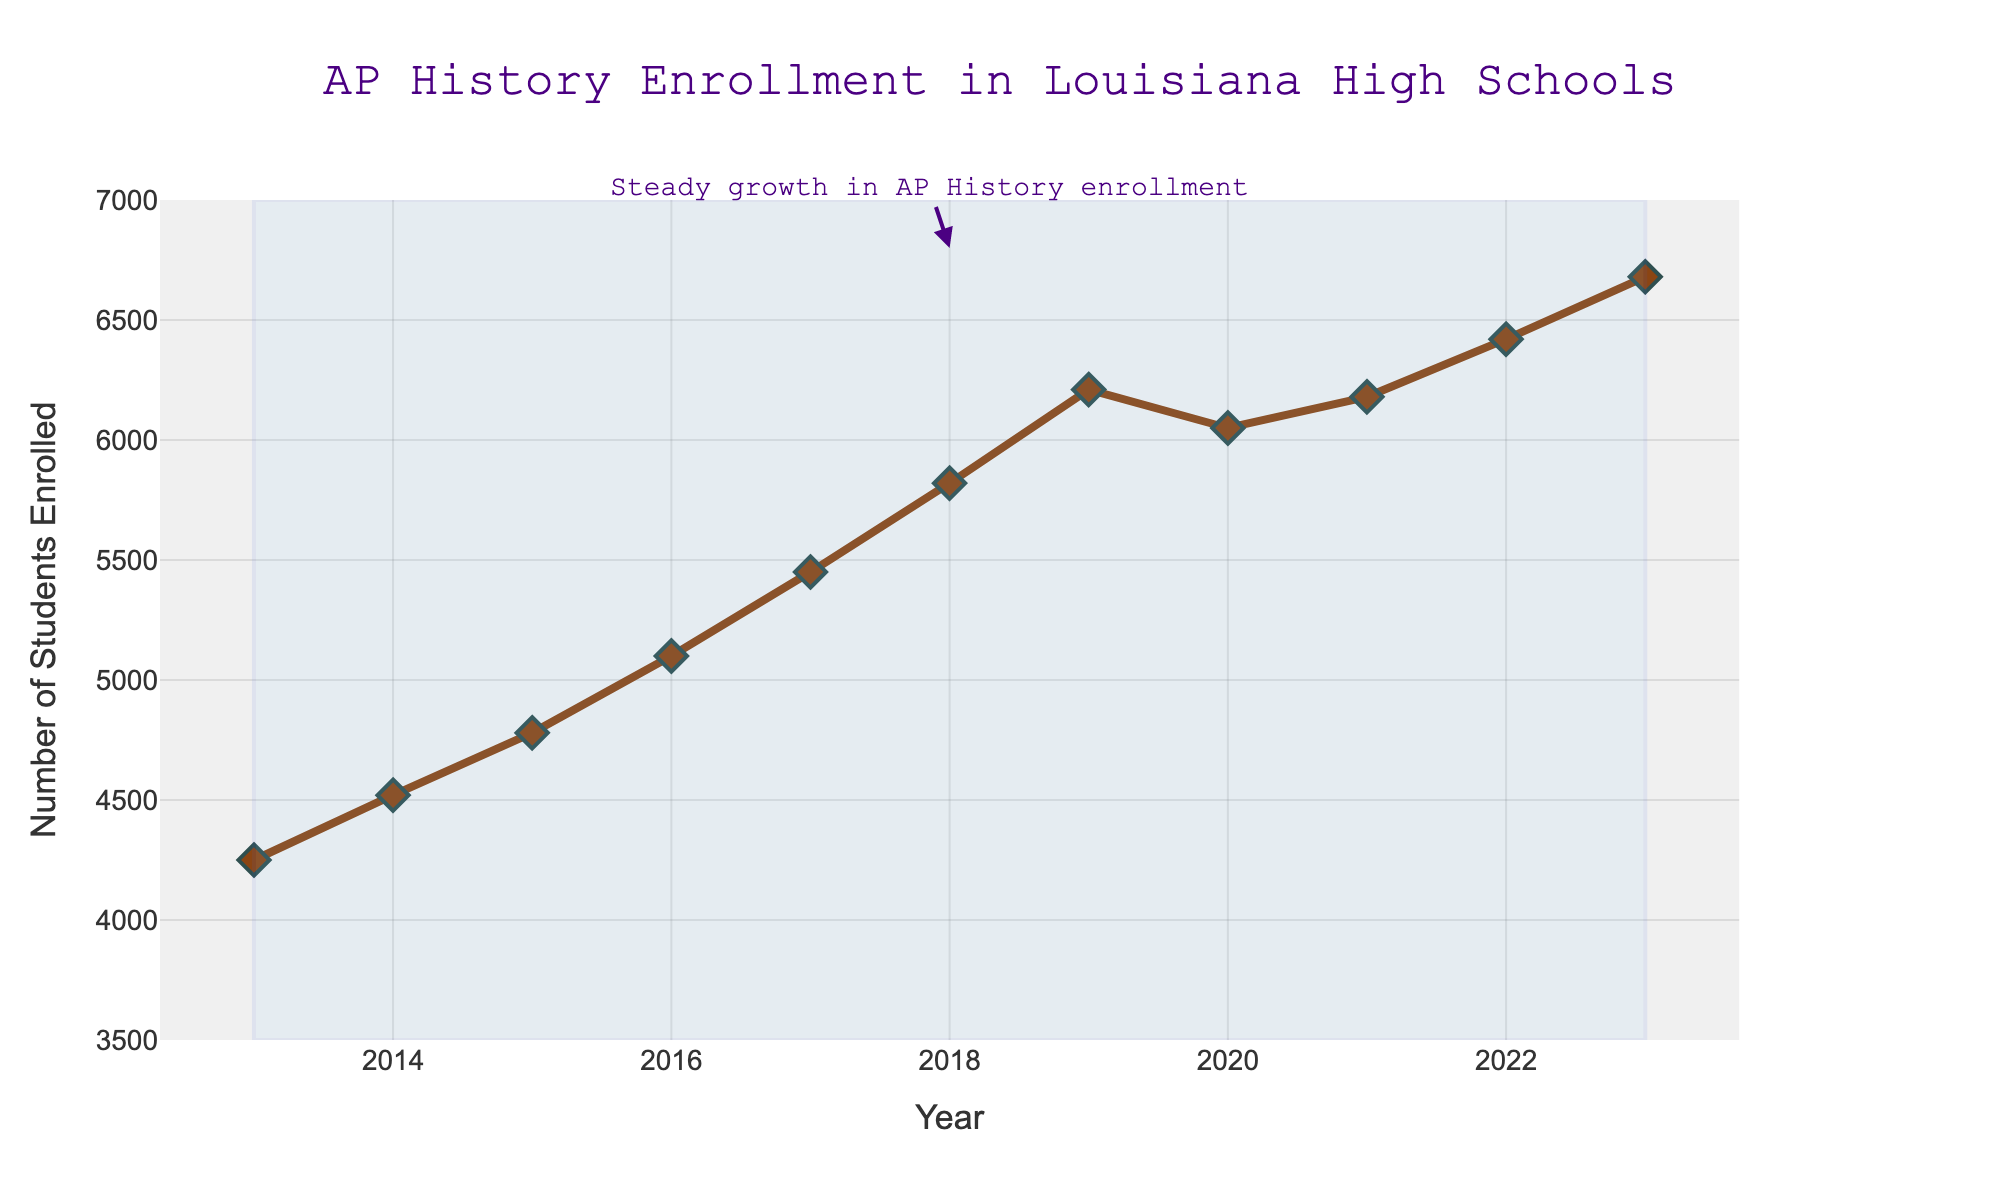What is the enrollment trend of AP History courses from 2013 to 2023? By looking at the figure, you can see that the line representing the number of students enrolled in AP History courses generally increases from 2013 to 2023. This indicates an upward trend.
Answer: Upward trend What was the AP History enrollment in 2017? Locate the data point on the vertical axis corresponding to the year 2017. The value is around 5450 students.
Answer: 5450 Between which two consecutive years did AP History enrollment see the largest increase? To find this, calculate the differences in enrollment for each consecutive year and identify the largest difference. From 2015 to 2016, the enrollment increased by 320, which is the largest increase.
Answer: 2015-2016 How many students were enrolled in AP History courses in the year with the lowest enrollment? Identify the year with the lowest data point which is 2013, and the value is 4250 students.
Answer: 4250 What is the average enrollment in AP History courses over the decade? Sum all the enrollment values from 2013 to 2023, then divide by the number of years (11). (4250 + 4520 + 4780 + 5100 + 5450 + 5820 + 6210 + 6050 + 6180 + 6420 + 6680) / 11 = 5523.64.
Answer: 5523.64 Which year had the highest AP History enrollment? Locate the highest point on the line chart, which corresponds to the year 2023 with 6680 enrollments.
Answer: 2023 Compare the enrollment in 2023 to that in 2013. How much did it increase? Subtract the enrollment in 2013 from the enrollment in 2023: 6680 - 4250 = 2430.
Answer: 2430 What unusual pattern do you notice around the year 2020? The line shows a slight decrease from 2019 to 2020, followed by a small recovery in the subsequent years.
Answer: Slight decrease in 2020 